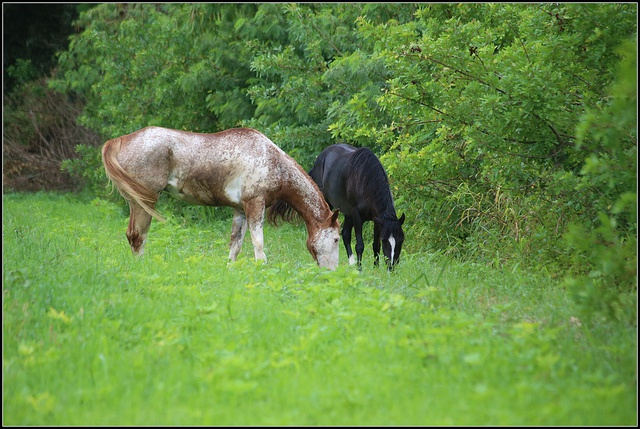Describe the objects in this image and their specific colors. I can see horse in black, darkgray, lightgray, and gray tones and horse in black, gray, and green tones in this image. 